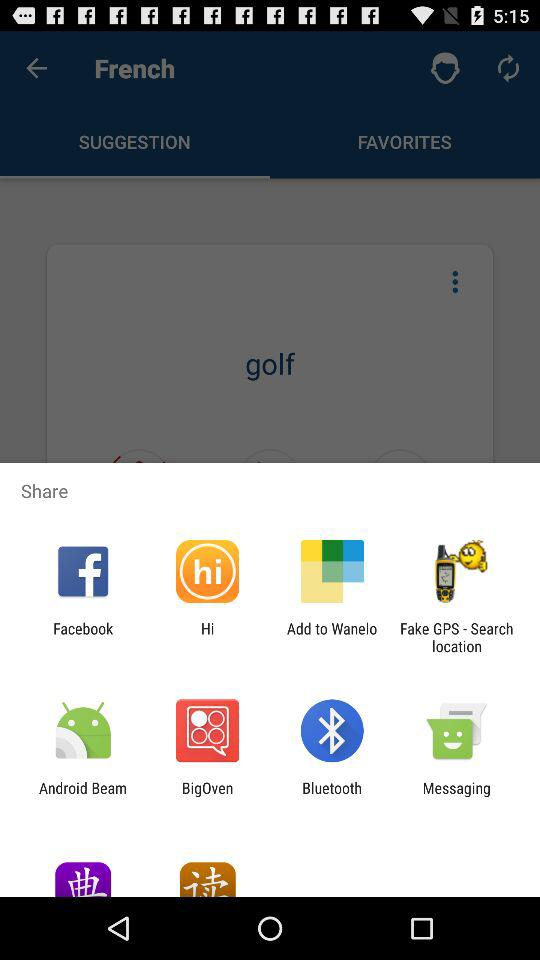Through which application can we share content? You can share content through "Facebook", "Hi", "Add to Wanelo", "Fake GPS - Search location", "Android Beam", "BigOven", "Bluetooth" and "Messaging". 